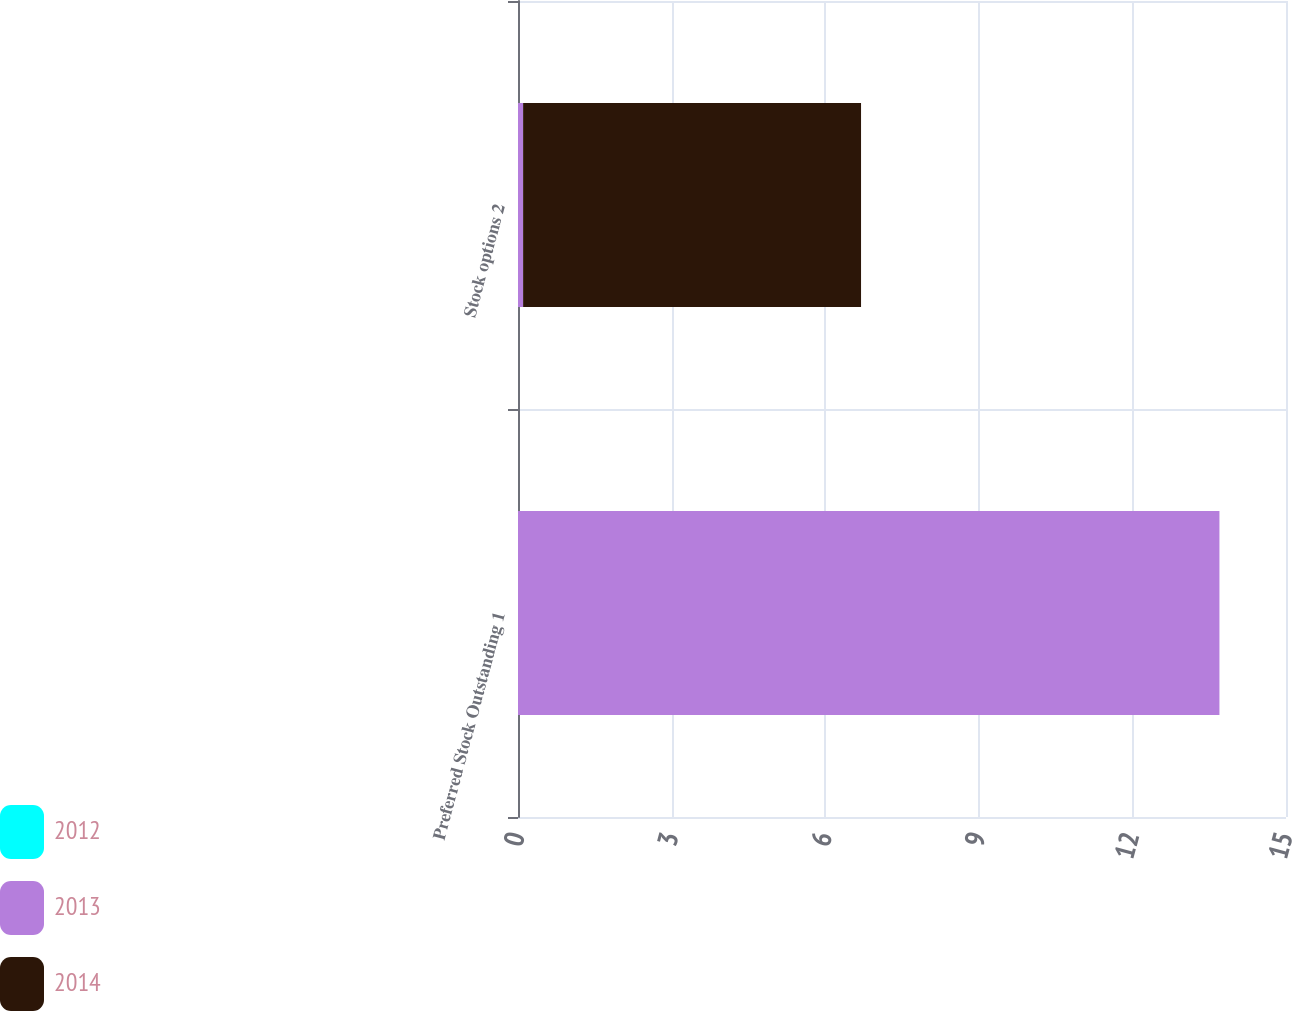<chart> <loc_0><loc_0><loc_500><loc_500><stacked_bar_chart><ecel><fcel>Preferred Stock Outstanding 1<fcel>Stock options 2<nl><fcel>2012<fcel>0<fcel>0<nl><fcel>2013<fcel>13.7<fcel>0.1<nl><fcel>2014<fcel>0<fcel>6.6<nl></chart> 